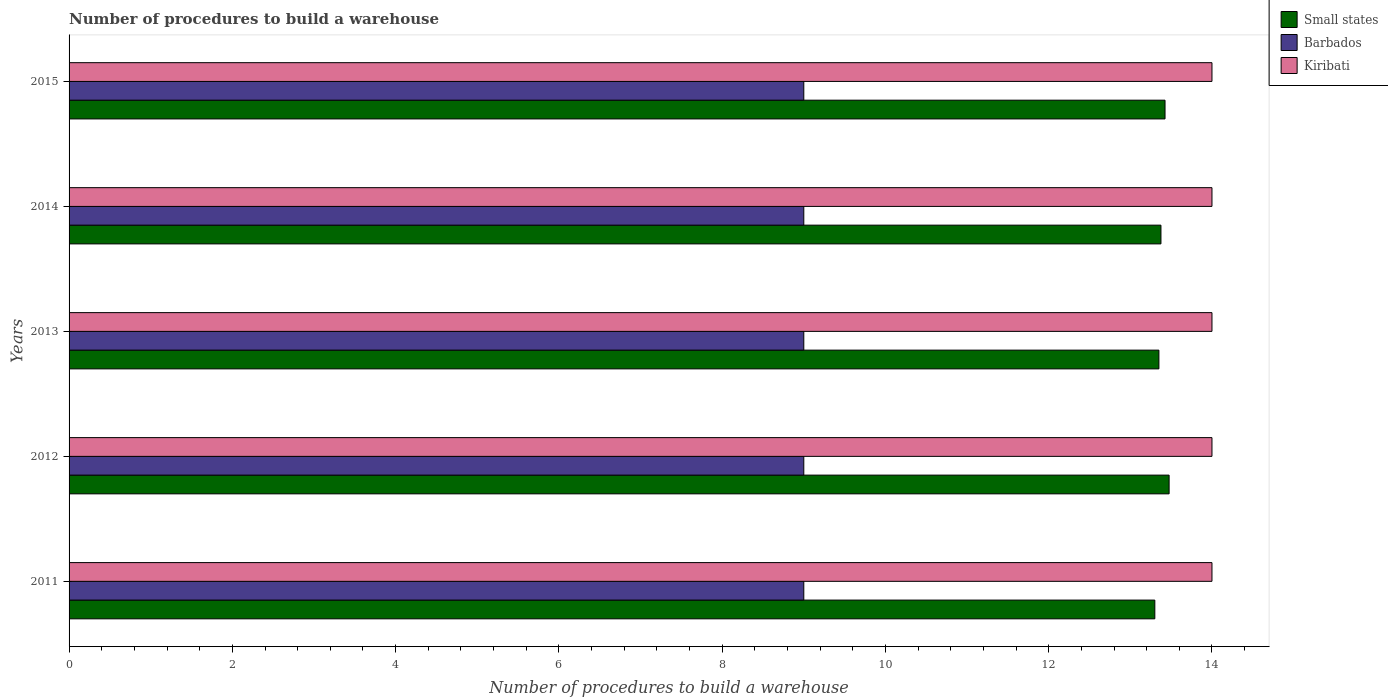How many different coloured bars are there?
Your answer should be compact. 3. How many groups of bars are there?
Your response must be concise. 5. How many bars are there on the 4th tick from the top?
Offer a terse response. 3. How many bars are there on the 3rd tick from the bottom?
Make the answer very short. 3. Across all years, what is the maximum number of procedures to build a warehouse in in Small states?
Keep it short and to the point. 13.47. Across all years, what is the minimum number of procedures to build a warehouse in in Small states?
Offer a terse response. 13.3. In which year was the number of procedures to build a warehouse in in Kiribati maximum?
Give a very brief answer. 2011. What is the total number of procedures to build a warehouse in in Kiribati in the graph?
Offer a very short reply. 70. What is the difference between the number of procedures to build a warehouse in in Small states in 2013 and that in 2014?
Keep it short and to the point. -0.03. What is the difference between the number of procedures to build a warehouse in in Kiribati in 2014 and the number of procedures to build a warehouse in in Small states in 2015?
Offer a very short reply. 0.57. In how many years, is the number of procedures to build a warehouse in in Kiribati greater than 5.6 ?
Your answer should be compact. 5. What is the ratio of the number of procedures to build a warehouse in in Small states in 2011 to that in 2013?
Give a very brief answer. 1. Is the difference between the number of procedures to build a warehouse in in Barbados in 2011 and 2014 greater than the difference between the number of procedures to build a warehouse in in Kiribati in 2011 and 2014?
Your response must be concise. No. What is the difference between the highest and the second highest number of procedures to build a warehouse in in Kiribati?
Make the answer very short. 0. What is the difference between the highest and the lowest number of procedures to build a warehouse in in Small states?
Your response must be concise. 0.17. What does the 2nd bar from the top in 2011 represents?
Your response must be concise. Barbados. What does the 1st bar from the bottom in 2015 represents?
Provide a short and direct response. Small states. Are all the bars in the graph horizontal?
Give a very brief answer. Yes. Does the graph contain grids?
Provide a short and direct response. No. Where does the legend appear in the graph?
Keep it short and to the point. Top right. How many legend labels are there?
Your answer should be compact. 3. What is the title of the graph?
Keep it short and to the point. Number of procedures to build a warehouse. Does "Latin America(developing only)" appear as one of the legend labels in the graph?
Your response must be concise. No. What is the label or title of the X-axis?
Your answer should be compact. Number of procedures to build a warehouse. What is the Number of procedures to build a warehouse of Small states in 2011?
Offer a very short reply. 13.3. What is the Number of procedures to build a warehouse of Barbados in 2011?
Your answer should be very brief. 9. What is the Number of procedures to build a warehouse of Kiribati in 2011?
Ensure brevity in your answer.  14. What is the Number of procedures to build a warehouse of Small states in 2012?
Your answer should be compact. 13.47. What is the Number of procedures to build a warehouse of Barbados in 2012?
Give a very brief answer. 9. What is the Number of procedures to build a warehouse of Kiribati in 2012?
Keep it short and to the point. 14. What is the Number of procedures to build a warehouse in Small states in 2013?
Give a very brief answer. 13.35. What is the Number of procedures to build a warehouse in Small states in 2014?
Give a very brief answer. 13.38. What is the Number of procedures to build a warehouse of Small states in 2015?
Make the answer very short. 13.43. What is the Number of procedures to build a warehouse in Barbados in 2015?
Keep it short and to the point. 9. Across all years, what is the maximum Number of procedures to build a warehouse in Small states?
Offer a very short reply. 13.47. Across all years, what is the minimum Number of procedures to build a warehouse of Barbados?
Offer a terse response. 9. What is the total Number of procedures to build a warehouse of Small states in the graph?
Keep it short and to the point. 66.92. What is the total Number of procedures to build a warehouse of Kiribati in the graph?
Your answer should be very brief. 70. What is the difference between the Number of procedures to build a warehouse in Small states in 2011 and that in 2012?
Make the answer very short. -0.17. What is the difference between the Number of procedures to build a warehouse of Barbados in 2011 and that in 2012?
Make the answer very short. 0. What is the difference between the Number of procedures to build a warehouse of Small states in 2011 and that in 2013?
Provide a succinct answer. -0.05. What is the difference between the Number of procedures to build a warehouse in Barbados in 2011 and that in 2013?
Your answer should be very brief. 0. What is the difference between the Number of procedures to build a warehouse of Small states in 2011 and that in 2014?
Keep it short and to the point. -0.07. What is the difference between the Number of procedures to build a warehouse of Barbados in 2011 and that in 2014?
Provide a succinct answer. 0. What is the difference between the Number of procedures to build a warehouse in Small states in 2011 and that in 2015?
Offer a very short reply. -0.12. What is the difference between the Number of procedures to build a warehouse of Kiribati in 2012 and that in 2013?
Ensure brevity in your answer.  0. What is the difference between the Number of procedures to build a warehouse in Barbados in 2012 and that in 2014?
Ensure brevity in your answer.  0. What is the difference between the Number of procedures to build a warehouse of Barbados in 2012 and that in 2015?
Make the answer very short. 0. What is the difference between the Number of procedures to build a warehouse of Small states in 2013 and that in 2014?
Provide a succinct answer. -0.03. What is the difference between the Number of procedures to build a warehouse of Barbados in 2013 and that in 2014?
Offer a very short reply. 0. What is the difference between the Number of procedures to build a warehouse in Small states in 2013 and that in 2015?
Your answer should be very brief. -0.07. What is the difference between the Number of procedures to build a warehouse in Small states in 2014 and that in 2015?
Your response must be concise. -0.05. What is the difference between the Number of procedures to build a warehouse of Small states in 2011 and the Number of procedures to build a warehouse of Kiribati in 2012?
Ensure brevity in your answer.  -0.7. What is the difference between the Number of procedures to build a warehouse in Small states in 2011 and the Number of procedures to build a warehouse in Barbados in 2013?
Give a very brief answer. 4.3. What is the difference between the Number of procedures to build a warehouse of Small states in 2011 and the Number of procedures to build a warehouse of Kiribati in 2014?
Your answer should be very brief. -0.7. What is the difference between the Number of procedures to build a warehouse in Barbados in 2011 and the Number of procedures to build a warehouse in Kiribati in 2014?
Provide a succinct answer. -5. What is the difference between the Number of procedures to build a warehouse in Small states in 2011 and the Number of procedures to build a warehouse in Barbados in 2015?
Make the answer very short. 4.3. What is the difference between the Number of procedures to build a warehouse in Small states in 2012 and the Number of procedures to build a warehouse in Barbados in 2013?
Your answer should be compact. 4.47. What is the difference between the Number of procedures to build a warehouse of Small states in 2012 and the Number of procedures to build a warehouse of Kiribati in 2013?
Provide a short and direct response. -0.53. What is the difference between the Number of procedures to build a warehouse of Small states in 2012 and the Number of procedures to build a warehouse of Barbados in 2014?
Provide a short and direct response. 4.47. What is the difference between the Number of procedures to build a warehouse in Small states in 2012 and the Number of procedures to build a warehouse in Kiribati in 2014?
Give a very brief answer. -0.53. What is the difference between the Number of procedures to build a warehouse in Barbados in 2012 and the Number of procedures to build a warehouse in Kiribati in 2014?
Your response must be concise. -5. What is the difference between the Number of procedures to build a warehouse in Small states in 2012 and the Number of procedures to build a warehouse in Barbados in 2015?
Give a very brief answer. 4.47. What is the difference between the Number of procedures to build a warehouse of Small states in 2012 and the Number of procedures to build a warehouse of Kiribati in 2015?
Your answer should be very brief. -0.53. What is the difference between the Number of procedures to build a warehouse of Barbados in 2012 and the Number of procedures to build a warehouse of Kiribati in 2015?
Your answer should be very brief. -5. What is the difference between the Number of procedures to build a warehouse of Small states in 2013 and the Number of procedures to build a warehouse of Barbados in 2014?
Your response must be concise. 4.35. What is the difference between the Number of procedures to build a warehouse of Small states in 2013 and the Number of procedures to build a warehouse of Kiribati in 2014?
Keep it short and to the point. -0.65. What is the difference between the Number of procedures to build a warehouse in Barbados in 2013 and the Number of procedures to build a warehouse in Kiribati in 2014?
Offer a terse response. -5. What is the difference between the Number of procedures to build a warehouse in Small states in 2013 and the Number of procedures to build a warehouse in Barbados in 2015?
Provide a short and direct response. 4.35. What is the difference between the Number of procedures to build a warehouse of Small states in 2013 and the Number of procedures to build a warehouse of Kiribati in 2015?
Your response must be concise. -0.65. What is the difference between the Number of procedures to build a warehouse of Barbados in 2013 and the Number of procedures to build a warehouse of Kiribati in 2015?
Your response must be concise. -5. What is the difference between the Number of procedures to build a warehouse of Small states in 2014 and the Number of procedures to build a warehouse of Barbados in 2015?
Your answer should be compact. 4.38. What is the difference between the Number of procedures to build a warehouse in Small states in 2014 and the Number of procedures to build a warehouse in Kiribati in 2015?
Offer a very short reply. -0.62. What is the difference between the Number of procedures to build a warehouse of Barbados in 2014 and the Number of procedures to build a warehouse of Kiribati in 2015?
Provide a succinct answer. -5. What is the average Number of procedures to build a warehouse in Small states per year?
Ensure brevity in your answer.  13.38. What is the average Number of procedures to build a warehouse in Kiribati per year?
Make the answer very short. 14. In the year 2011, what is the difference between the Number of procedures to build a warehouse in Small states and Number of procedures to build a warehouse in Barbados?
Your answer should be compact. 4.3. In the year 2011, what is the difference between the Number of procedures to build a warehouse in Small states and Number of procedures to build a warehouse in Kiribati?
Offer a very short reply. -0.7. In the year 2012, what is the difference between the Number of procedures to build a warehouse in Small states and Number of procedures to build a warehouse in Barbados?
Provide a succinct answer. 4.47. In the year 2012, what is the difference between the Number of procedures to build a warehouse of Small states and Number of procedures to build a warehouse of Kiribati?
Your response must be concise. -0.53. In the year 2012, what is the difference between the Number of procedures to build a warehouse of Barbados and Number of procedures to build a warehouse of Kiribati?
Your answer should be very brief. -5. In the year 2013, what is the difference between the Number of procedures to build a warehouse in Small states and Number of procedures to build a warehouse in Barbados?
Offer a terse response. 4.35. In the year 2013, what is the difference between the Number of procedures to build a warehouse in Small states and Number of procedures to build a warehouse in Kiribati?
Offer a terse response. -0.65. In the year 2014, what is the difference between the Number of procedures to build a warehouse in Small states and Number of procedures to build a warehouse in Barbados?
Your response must be concise. 4.38. In the year 2014, what is the difference between the Number of procedures to build a warehouse in Small states and Number of procedures to build a warehouse in Kiribati?
Provide a succinct answer. -0.62. In the year 2015, what is the difference between the Number of procedures to build a warehouse of Small states and Number of procedures to build a warehouse of Barbados?
Offer a very short reply. 4.42. In the year 2015, what is the difference between the Number of procedures to build a warehouse in Small states and Number of procedures to build a warehouse in Kiribati?
Offer a terse response. -0.57. In the year 2015, what is the difference between the Number of procedures to build a warehouse in Barbados and Number of procedures to build a warehouse in Kiribati?
Provide a short and direct response. -5. What is the ratio of the Number of procedures to build a warehouse in Small states in 2011 to that in 2013?
Offer a very short reply. 1. What is the ratio of the Number of procedures to build a warehouse of Barbados in 2011 to that in 2013?
Provide a short and direct response. 1. What is the ratio of the Number of procedures to build a warehouse of Kiribati in 2011 to that in 2013?
Provide a short and direct response. 1. What is the ratio of the Number of procedures to build a warehouse of Barbados in 2011 to that in 2015?
Provide a short and direct response. 1. What is the ratio of the Number of procedures to build a warehouse of Kiribati in 2011 to that in 2015?
Make the answer very short. 1. What is the ratio of the Number of procedures to build a warehouse of Small states in 2012 to that in 2013?
Give a very brief answer. 1.01. What is the ratio of the Number of procedures to build a warehouse in Barbados in 2012 to that in 2013?
Your answer should be compact. 1. What is the ratio of the Number of procedures to build a warehouse of Small states in 2012 to that in 2014?
Your answer should be very brief. 1.01. What is the ratio of the Number of procedures to build a warehouse of Small states in 2012 to that in 2015?
Provide a short and direct response. 1. What is the ratio of the Number of procedures to build a warehouse in Small states in 2013 to that in 2014?
Keep it short and to the point. 1. What is the ratio of the Number of procedures to build a warehouse of Barbados in 2013 to that in 2014?
Make the answer very short. 1. What is the ratio of the Number of procedures to build a warehouse of Small states in 2013 to that in 2015?
Provide a succinct answer. 0.99. What is the ratio of the Number of procedures to build a warehouse in Barbados in 2013 to that in 2015?
Keep it short and to the point. 1. What is the ratio of the Number of procedures to build a warehouse in Kiribati in 2013 to that in 2015?
Ensure brevity in your answer.  1. What is the difference between the highest and the second highest Number of procedures to build a warehouse of Kiribati?
Provide a short and direct response. 0. What is the difference between the highest and the lowest Number of procedures to build a warehouse in Small states?
Your answer should be very brief. 0.17. What is the difference between the highest and the lowest Number of procedures to build a warehouse of Kiribati?
Make the answer very short. 0. 